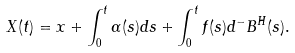Convert formula to latex. <formula><loc_0><loc_0><loc_500><loc_500>X ( t ) = x + \int ^ { t } _ { 0 } \alpha ( s ) d s + \int ^ { t } _ { 0 } f ( s ) d ^ { - } B ^ { H } ( s ) .</formula> 